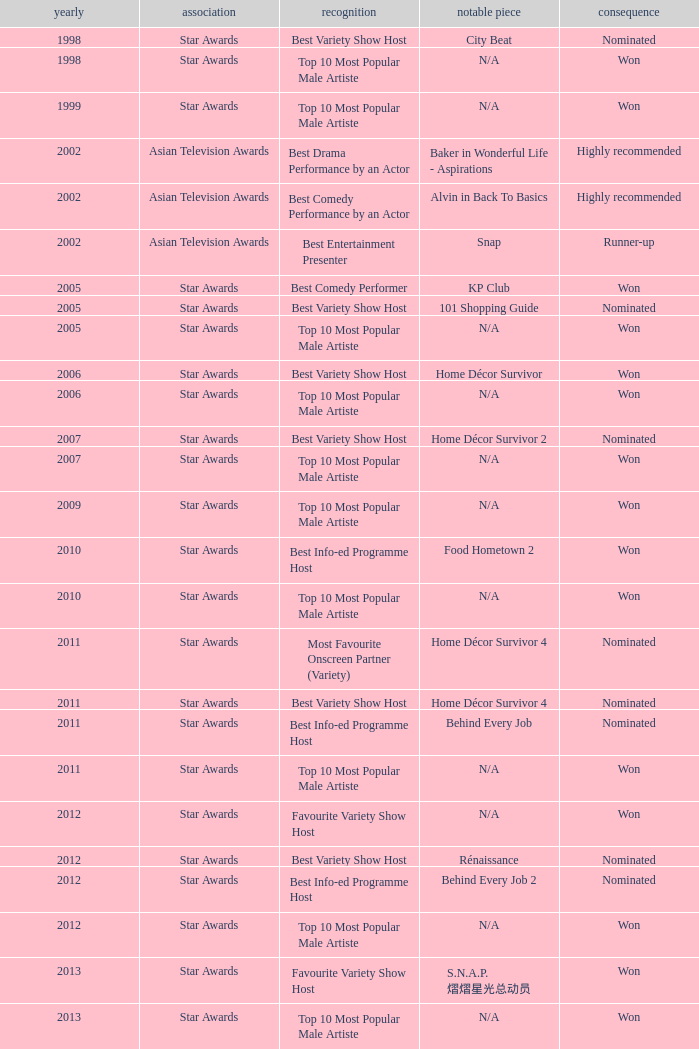What is the award for the Star Awards earlier than 2005 and the result is won? Top 10 Most Popular Male Artiste, Top 10 Most Popular Male Artiste. 